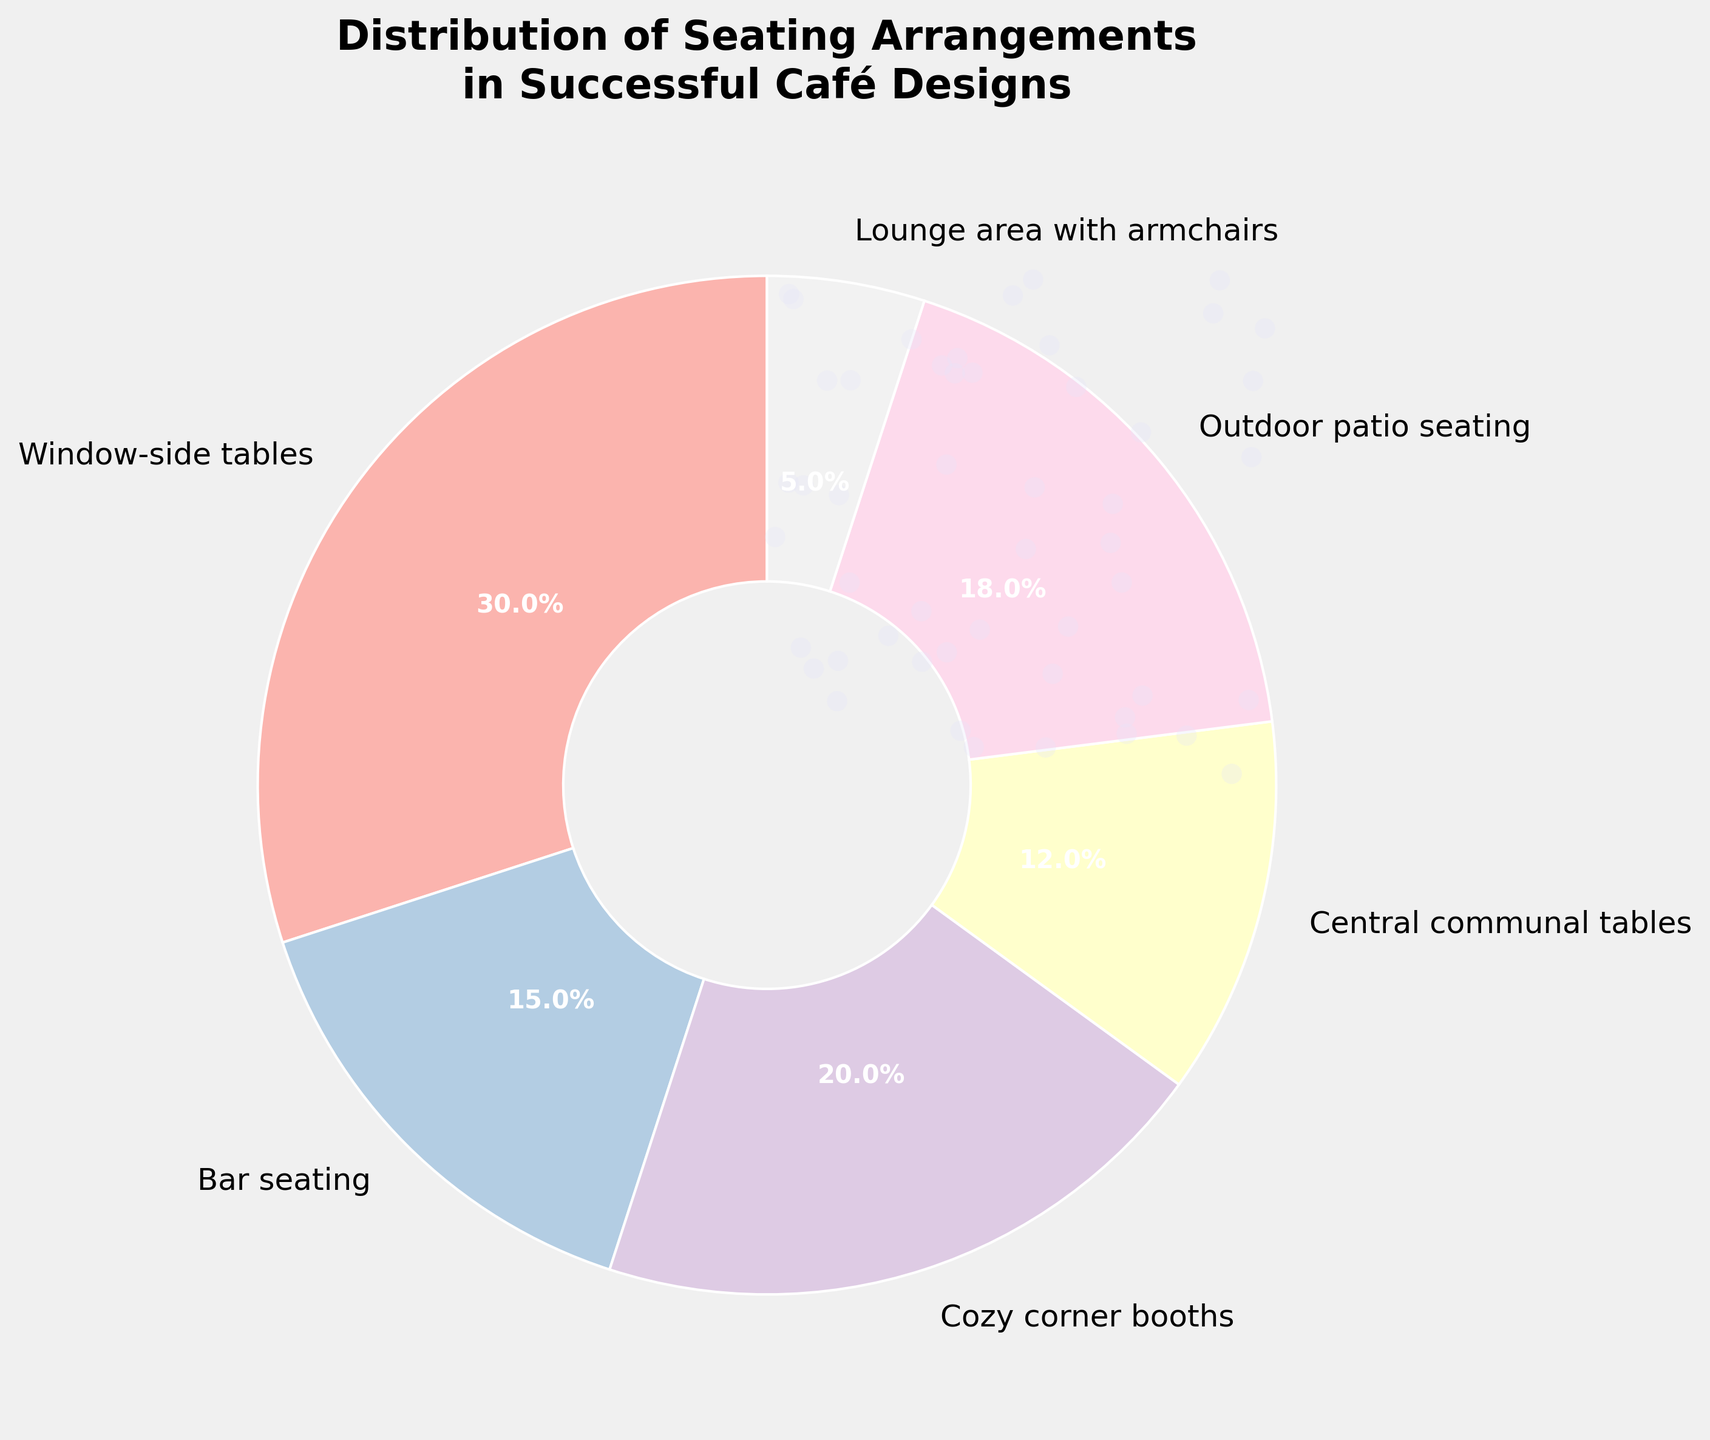Which seating arrangement occupies the largest percentage? Identify the segment in the pie chart with the highest percentage label. The "Window-side tables" segment has a label of 30%, which is the highest.
Answer: Window-side tables What is the combined percentage of Bar seating and Cozy corner booths? Locate the segments for "Bar seating" and "Cozy corner booths" in the pie chart. The percentage for "Bar seating" is 15%, and for "Cozy corner booths" is 20%. Add them together (15% + 20% = 35%).
Answer: 35% Which has a higher percentage, Outdoor patio seating or Central communal tables? Compare the percentage labels on the pie chart for "Outdoor patio seating" and "Central communal tables." "Outdoor patio seating" is 18%, and "Central communal tables" is 12%.
Answer: Outdoor patio seating How does the percentage of Lounge area with armchairs compare to the sum of Bar seating and Central communal tables? Locate the percentages for "Lounge area with armchairs", "Bar seating", and "Central communal tables" in the pie chart. Lounge area with armchairs is 5%, Bar seating is 15%, and Central communal tables are 12%. Sum the latter two (15% + 12% = 27%) and compare it to 5%.
Answer: Less What's the difference in percentage between Window-side tables and Central communal tables? Find the percentages for "Window-side tables" (30%) and "Central communal tables" (12%). Subtract the latter from the former (30% - 12% = 18%).
Answer: 18% 